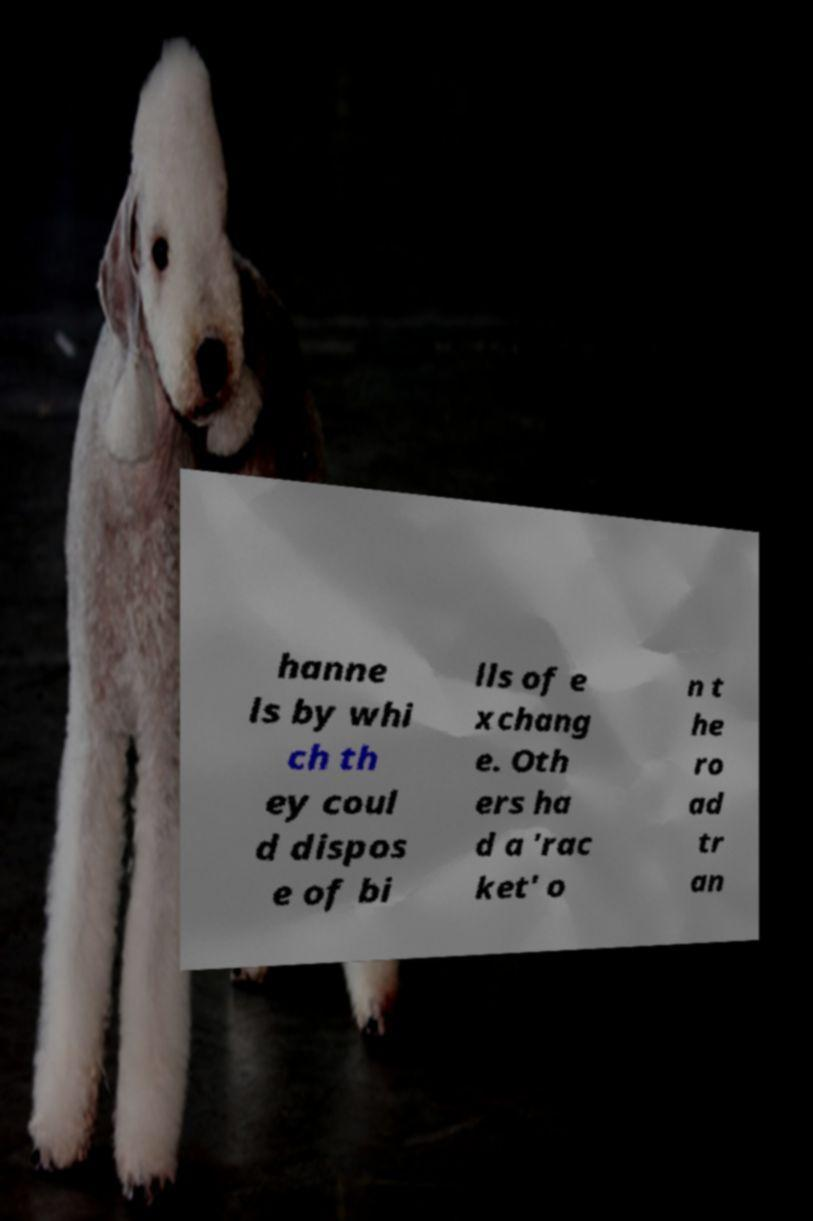What messages or text are displayed in this image? I need them in a readable, typed format. hanne ls by whi ch th ey coul d dispos e of bi lls of e xchang e. Oth ers ha d a 'rac ket' o n t he ro ad tr an 